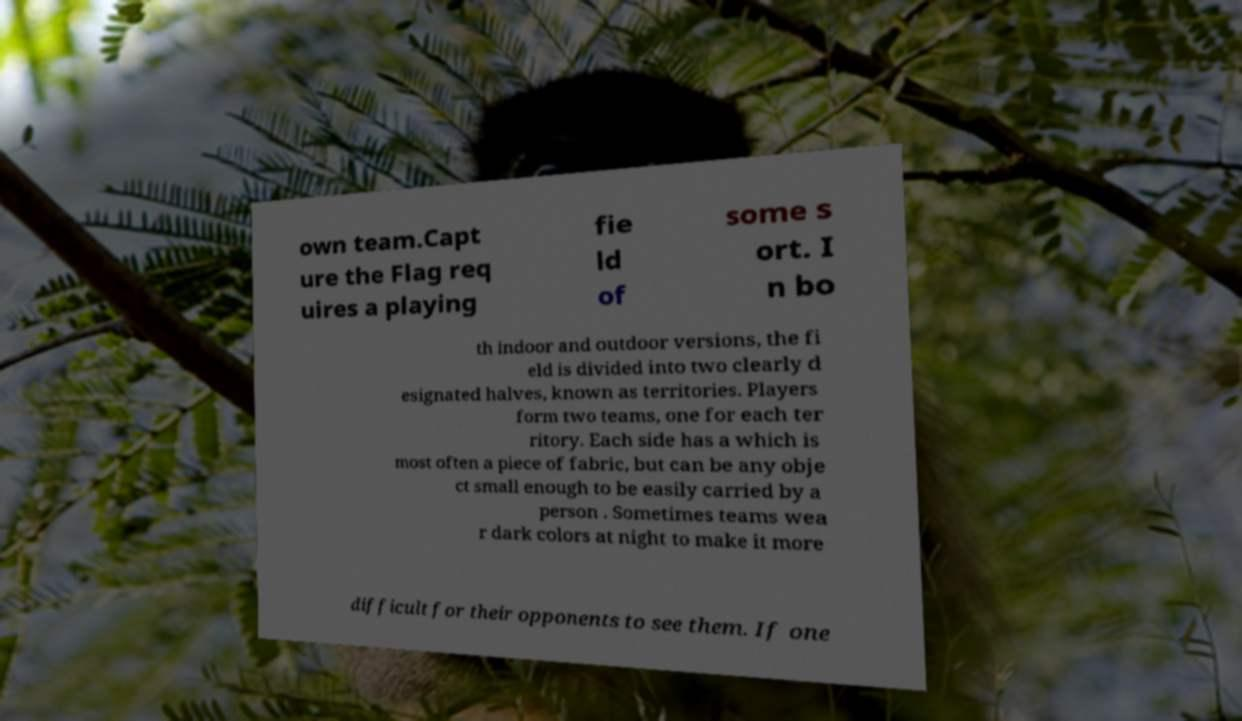What messages or text are displayed in this image? I need them in a readable, typed format. own team.Capt ure the Flag req uires a playing fie ld of some s ort. I n bo th indoor and outdoor versions, the fi eld is divided into two clearly d esignated halves, known as territories. Players form two teams, one for each ter ritory. Each side has a which is most often a piece of fabric, but can be any obje ct small enough to be easily carried by a person . Sometimes teams wea r dark colors at night to make it more difficult for their opponents to see them. If one 